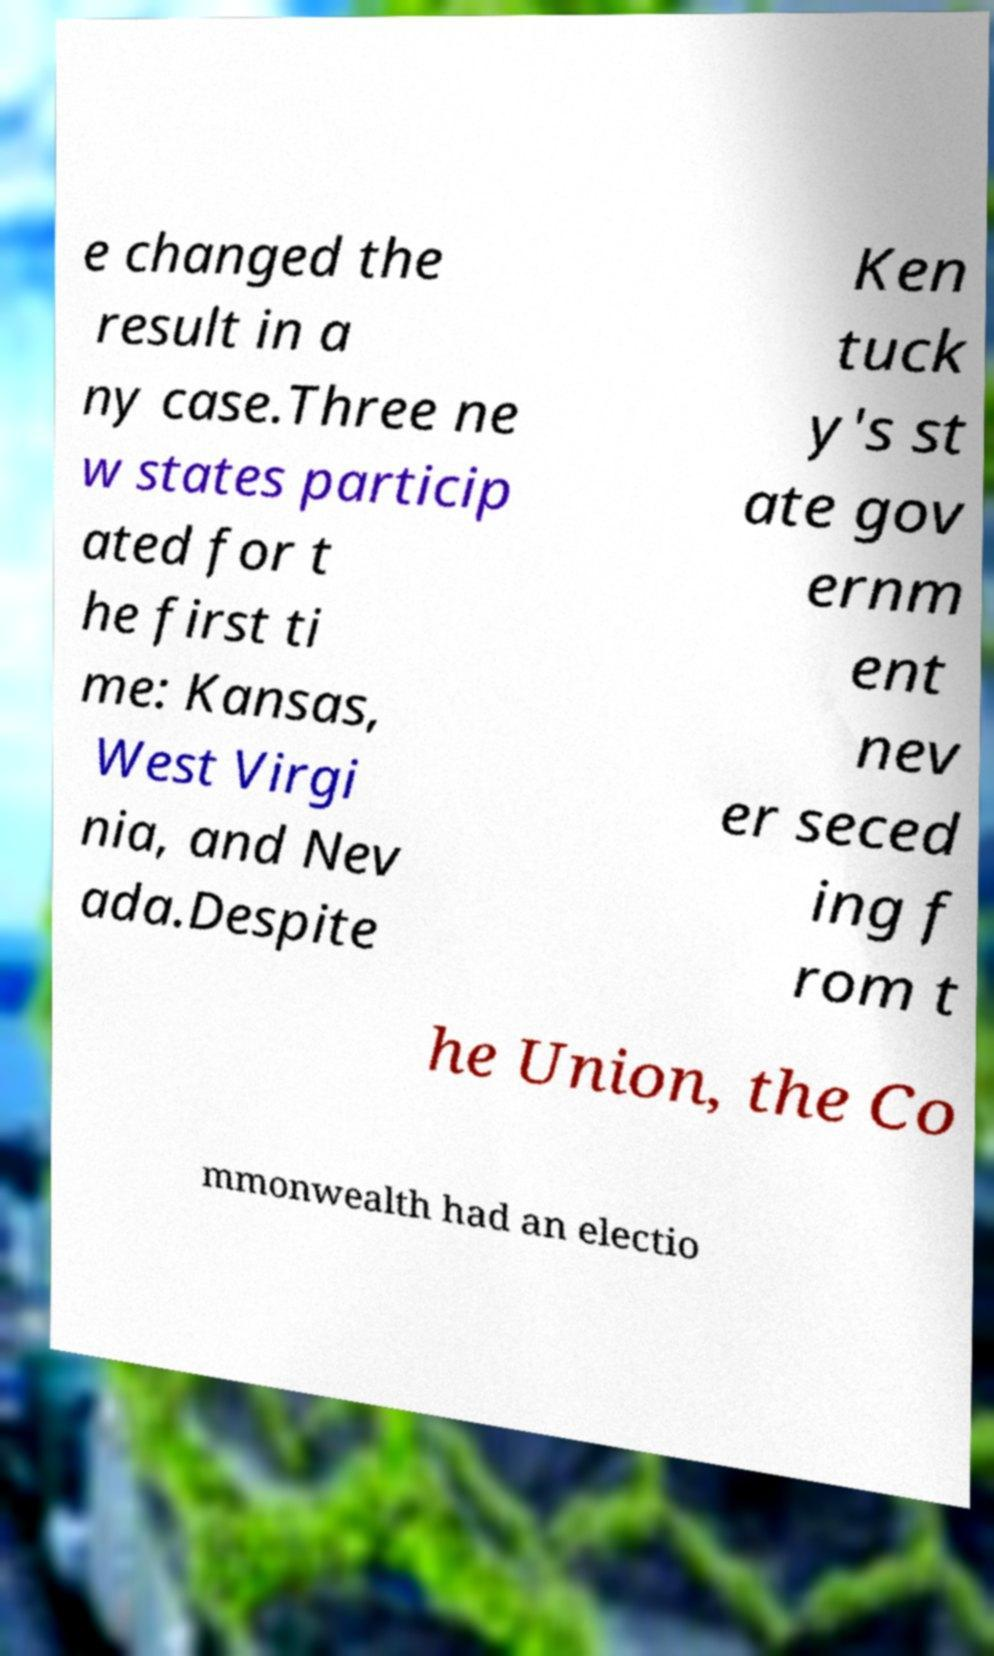Could you assist in decoding the text presented in this image and type it out clearly? e changed the result in a ny case.Three ne w states particip ated for t he first ti me: Kansas, West Virgi nia, and Nev ada.Despite Ken tuck y's st ate gov ernm ent nev er seced ing f rom t he Union, the Co mmonwealth had an electio 